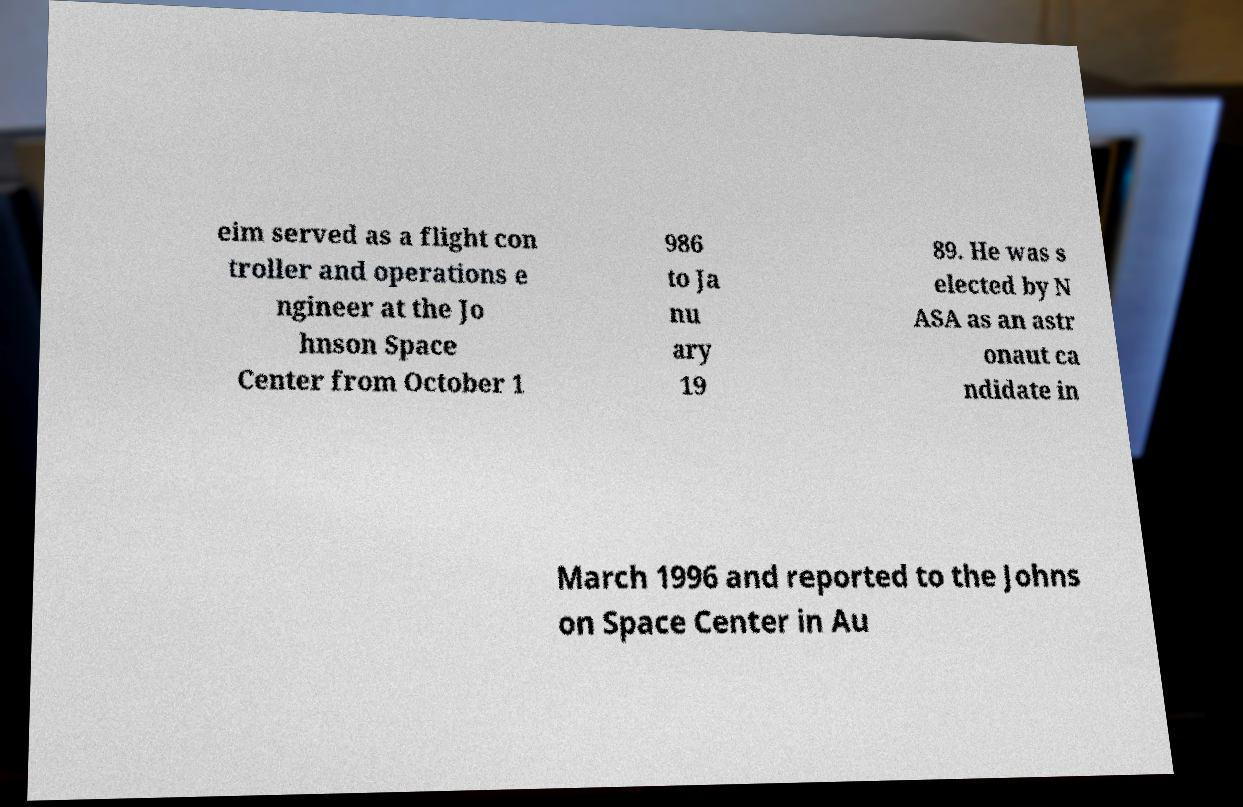Could you assist in decoding the text presented in this image and type it out clearly? eim served as a flight con troller and operations e ngineer at the Jo hnson Space Center from October 1 986 to Ja nu ary 19 89. He was s elected by N ASA as an astr onaut ca ndidate in March 1996 and reported to the Johns on Space Center in Au 